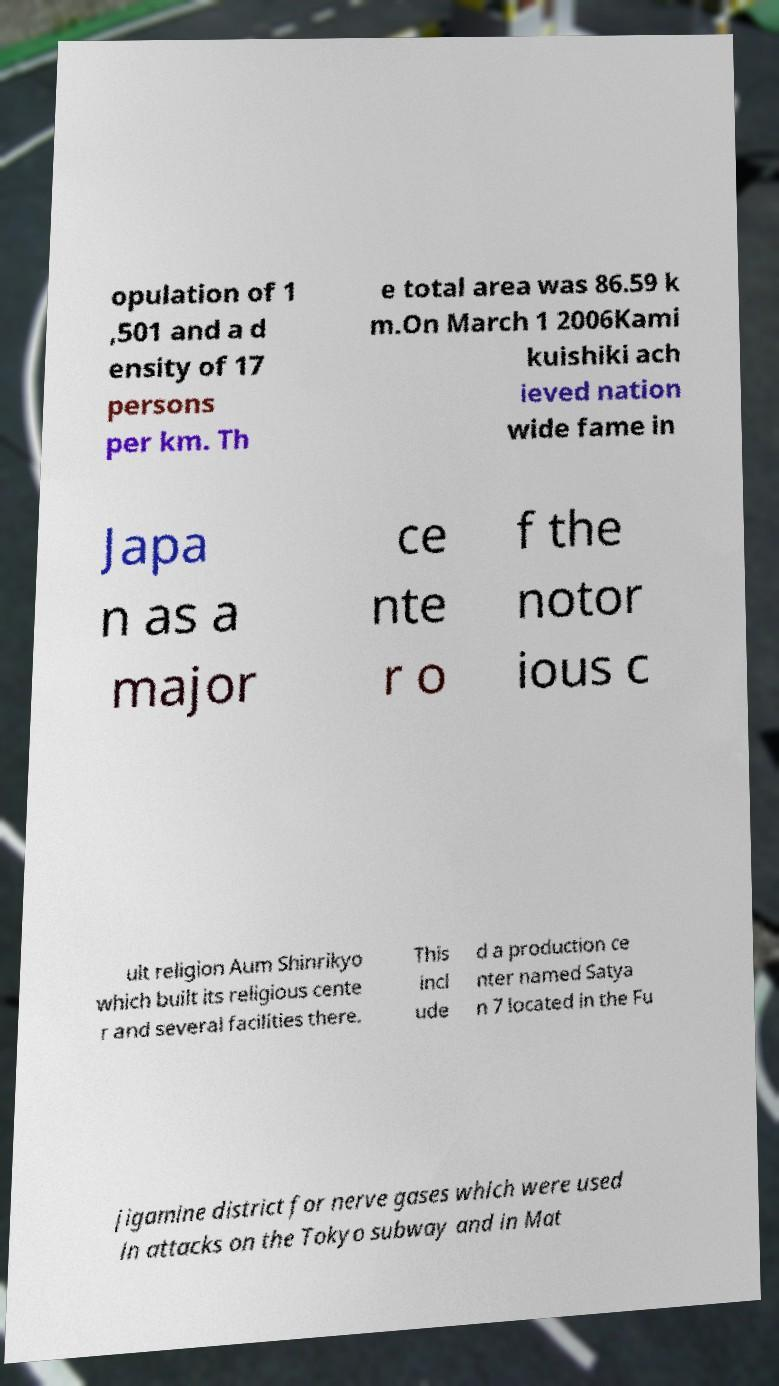What messages or text are displayed in this image? I need them in a readable, typed format. opulation of 1 ,501 and a d ensity of 17 persons per km. Th e total area was 86.59 k m.On March 1 2006Kami kuishiki ach ieved nation wide fame in Japa n as a major ce nte r o f the notor ious c ult religion Aum Shinrikyo which built its religious cente r and several facilities there. This incl ude d a production ce nter named Satya n 7 located in the Fu jigamine district for nerve gases which were used in attacks on the Tokyo subway and in Mat 